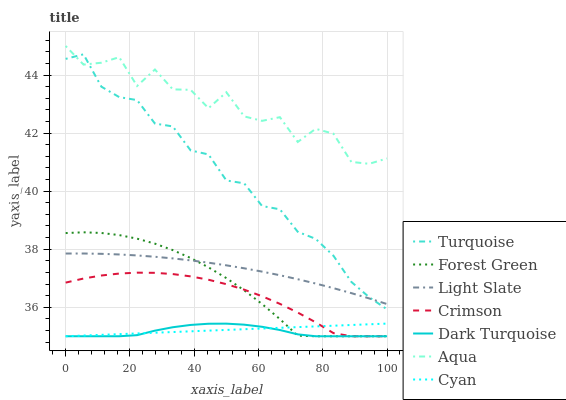Does Light Slate have the minimum area under the curve?
Answer yes or no. No. Does Light Slate have the maximum area under the curve?
Answer yes or no. No. Is Light Slate the smoothest?
Answer yes or no. No. Is Light Slate the roughest?
Answer yes or no. No. Does Light Slate have the lowest value?
Answer yes or no. No. Does Light Slate have the highest value?
Answer yes or no. No. Is Crimson less than Light Slate?
Answer yes or no. Yes. Is Aqua greater than Light Slate?
Answer yes or no. Yes. Does Crimson intersect Light Slate?
Answer yes or no. No. 